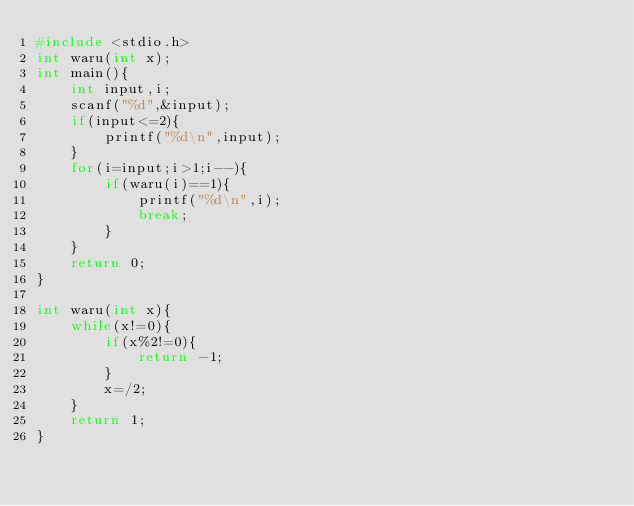<code> <loc_0><loc_0><loc_500><loc_500><_C_>#include <stdio.h>
int waru(int x);
int main(){
    int input,i;
    scanf("%d",&input);
    if(input<=2){
        printf("%d\n",input);
    }
    for(i=input;i>1;i--){
        if(waru(i)==1){
            printf("%d\n",i);
            break;
        }
    }
    return 0;
}

int waru(int x){
    while(x!=0){
        if(x%2!=0){
            return -1;
        }
        x=/2;
    }
    return 1;
}</code> 